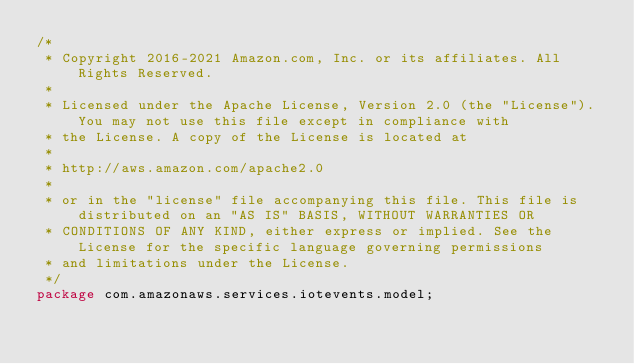<code> <loc_0><loc_0><loc_500><loc_500><_Java_>/*
 * Copyright 2016-2021 Amazon.com, Inc. or its affiliates. All Rights Reserved.
 * 
 * Licensed under the Apache License, Version 2.0 (the "License"). You may not use this file except in compliance with
 * the License. A copy of the License is located at
 * 
 * http://aws.amazon.com/apache2.0
 * 
 * or in the "license" file accompanying this file. This file is distributed on an "AS IS" BASIS, WITHOUT WARRANTIES OR
 * CONDITIONS OF ANY KIND, either express or implied. See the License for the specific language governing permissions
 * and limitations under the License.
 */
package com.amazonaws.services.iotevents.model;
</code> 